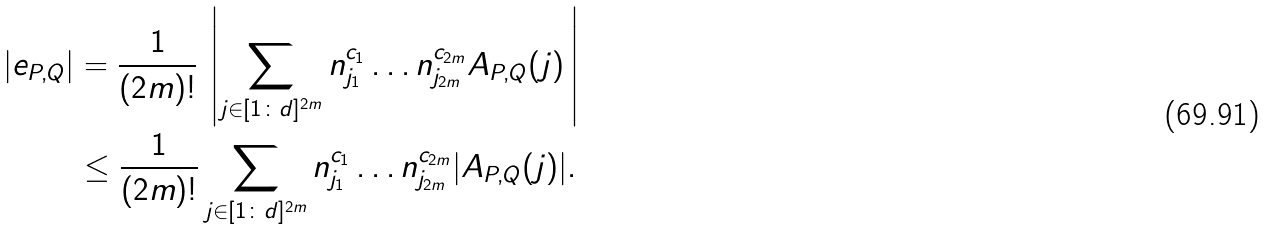Convert formula to latex. <formula><loc_0><loc_0><loc_500><loc_500>| e _ { P , Q } | & = \frac { 1 } { ( 2 m ) ! } \, \left | \sum _ { { j } \in [ 1 \colon d ] ^ { 2 m } } n _ { j _ { 1 } } ^ { c _ { 1 } } \dots n _ { j _ { 2 m } } ^ { c _ { 2 m } } A _ { P , Q } ( { j } ) \, \right | \\ & \leq \frac { 1 } { ( 2 m ) ! } \sum _ { { j } \in [ 1 \colon d ] ^ { 2 m } } n _ { j _ { 1 } } ^ { c _ { 1 } } \dots n _ { j _ { 2 m } } ^ { c _ { 2 m } } | A _ { P , Q } ( { j } ) | .</formula> 